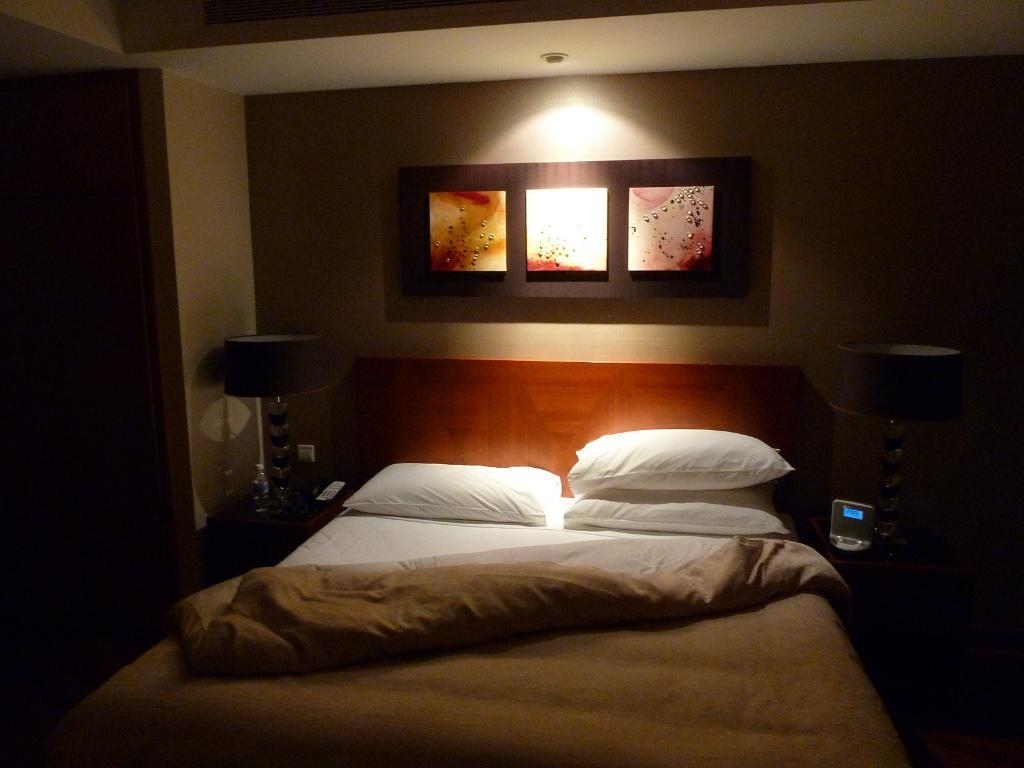What is the main object in the center of the image? There is a bed in the center of the image. What is covering the bed? The bed has a bed sheet. How many pillows are on the bed? There are three pillows on the bed. What can be seen behind the bed? There is a wall behind the bed. What type of lighting is present beside the bed? There is a table lamp beside the bed. What direction are the toes pointing on the person in the image? There are no people or toes visible in the image; it only shows a bed, bed sheet, pillows, a wall, and a table lamp. 